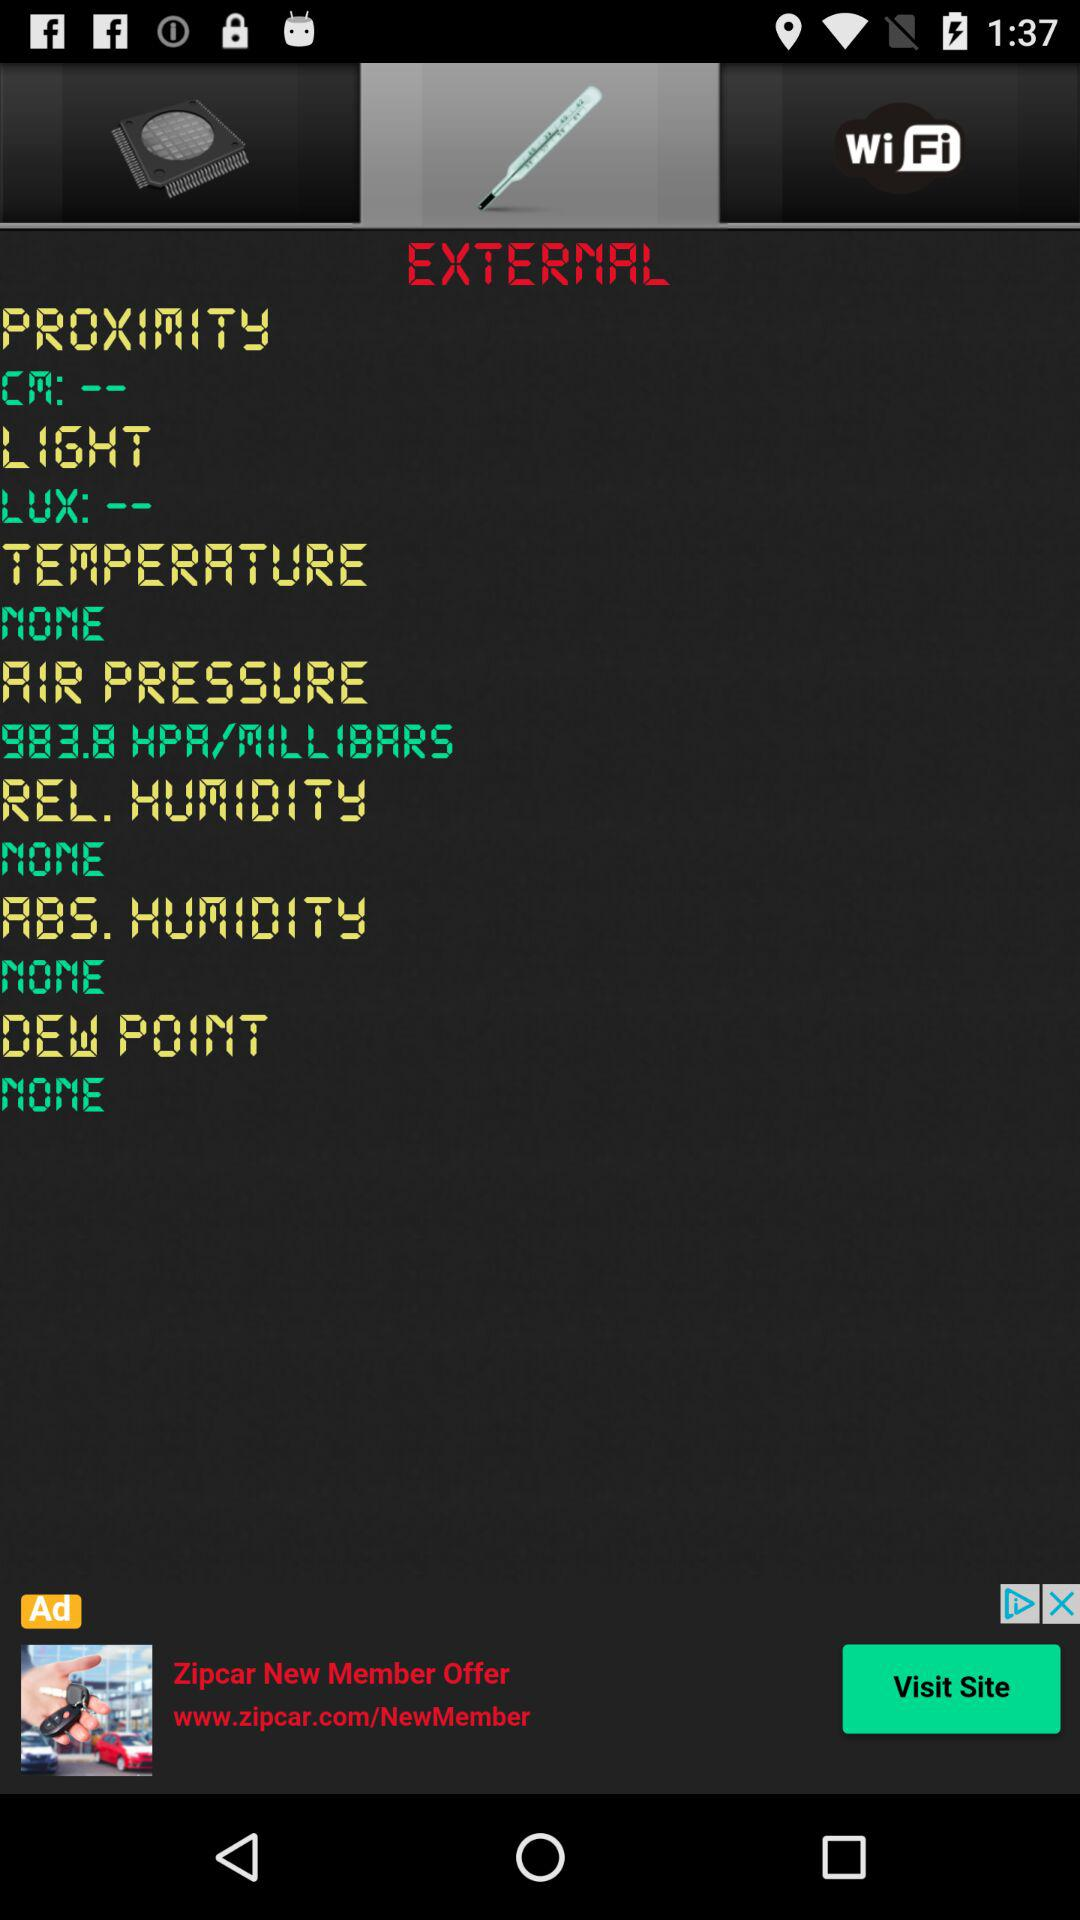What is the status of the "AIR PRESSURE"? The status is 983.8 HPA/MILLIBARS. 